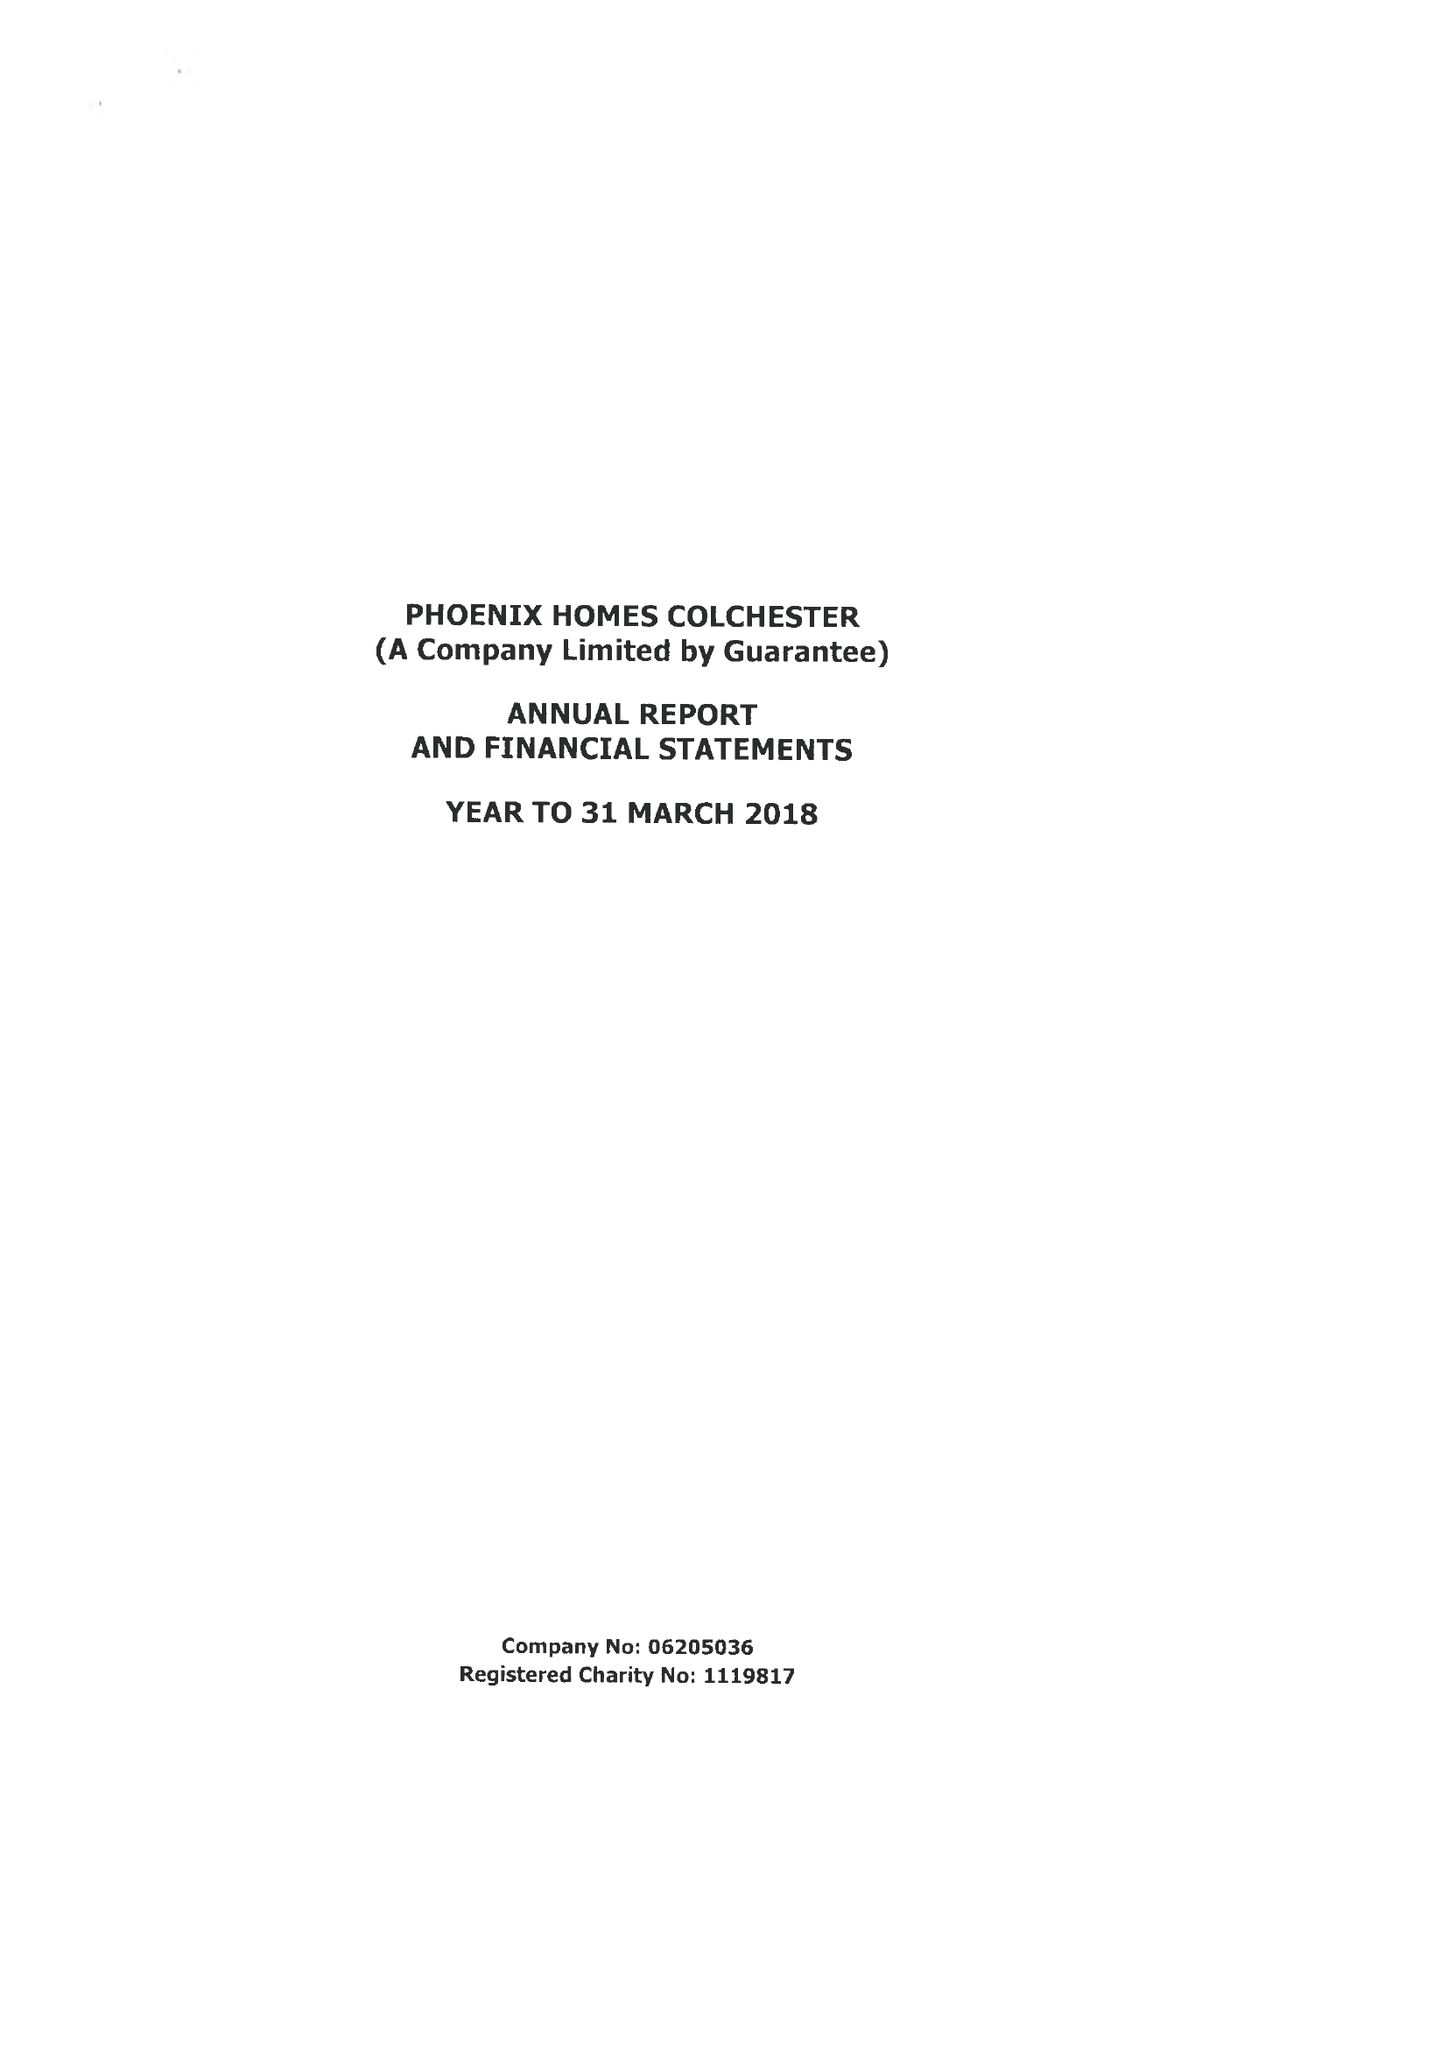What is the value for the charity_number?
Answer the question using a single word or phrase. 1119817 